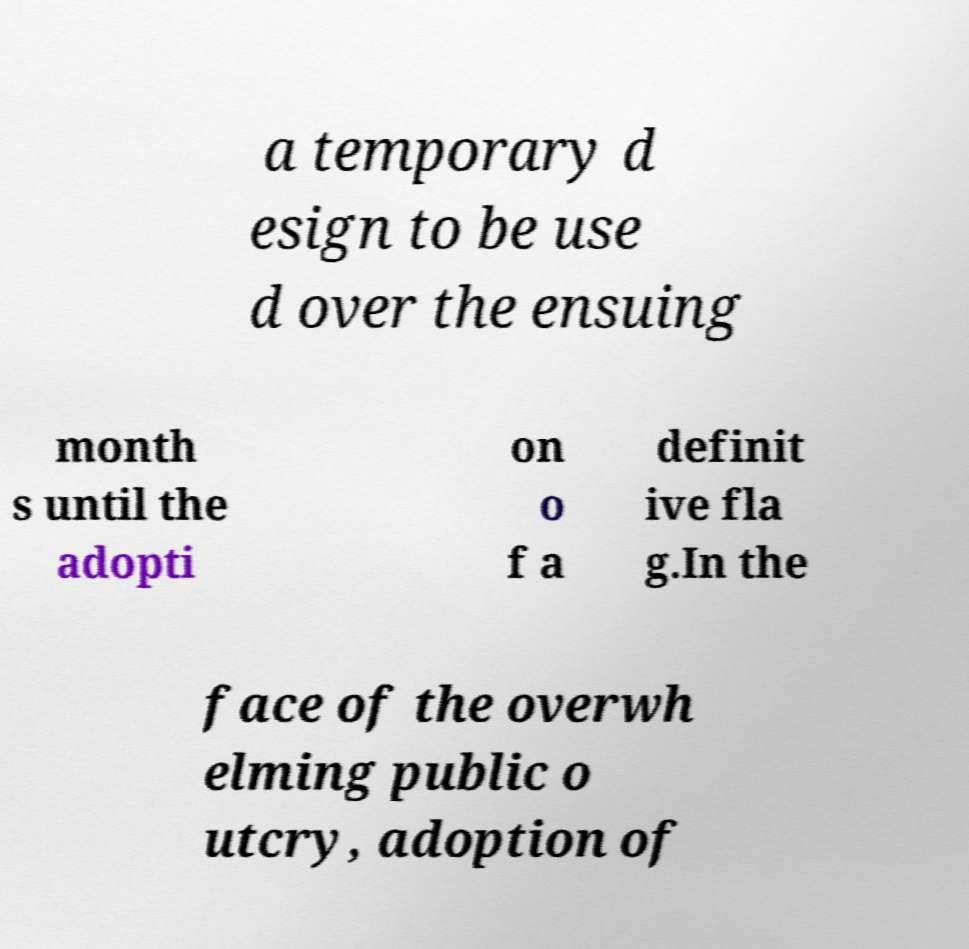Could you assist in decoding the text presented in this image and type it out clearly? a temporary d esign to be use d over the ensuing month s until the adopti on o f a definit ive fla g.In the face of the overwh elming public o utcry, adoption of 